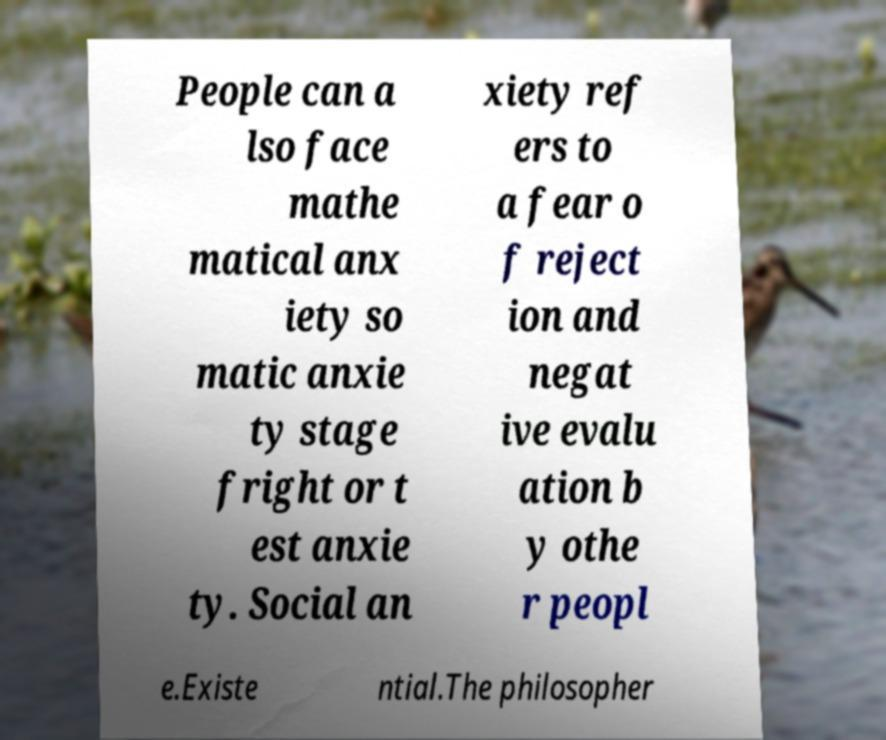What messages or text are displayed in this image? I need them in a readable, typed format. People can a lso face mathe matical anx iety so matic anxie ty stage fright or t est anxie ty. Social an xiety ref ers to a fear o f reject ion and negat ive evalu ation b y othe r peopl e.Existe ntial.The philosopher 